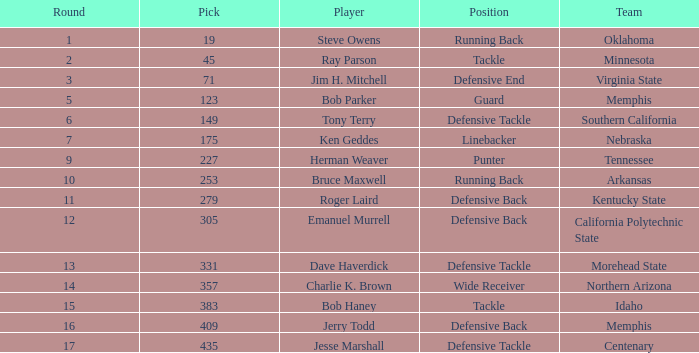What is the lowest draft position for dave haverdick, the defensive tackle player? 331.0. 